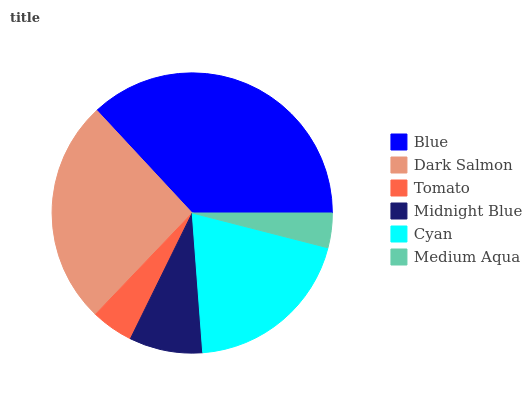Is Medium Aqua the minimum?
Answer yes or no. Yes. Is Blue the maximum?
Answer yes or no. Yes. Is Dark Salmon the minimum?
Answer yes or no. No. Is Dark Salmon the maximum?
Answer yes or no. No. Is Blue greater than Dark Salmon?
Answer yes or no. Yes. Is Dark Salmon less than Blue?
Answer yes or no. Yes. Is Dark Salmon greater than Blue?
Answer yes or no. No. Is Blue less than Dark Salmon?
Answer yes or no. No. Is Cyan the high median?
Answer yes or no. Yes. Is Midnight Blue the low median?
Answer yes or no. Yes. Is Medium Aqua the high median?
Answer yes or no. No. Is Dark Salmon the low median?
Answer yes or no. No. 